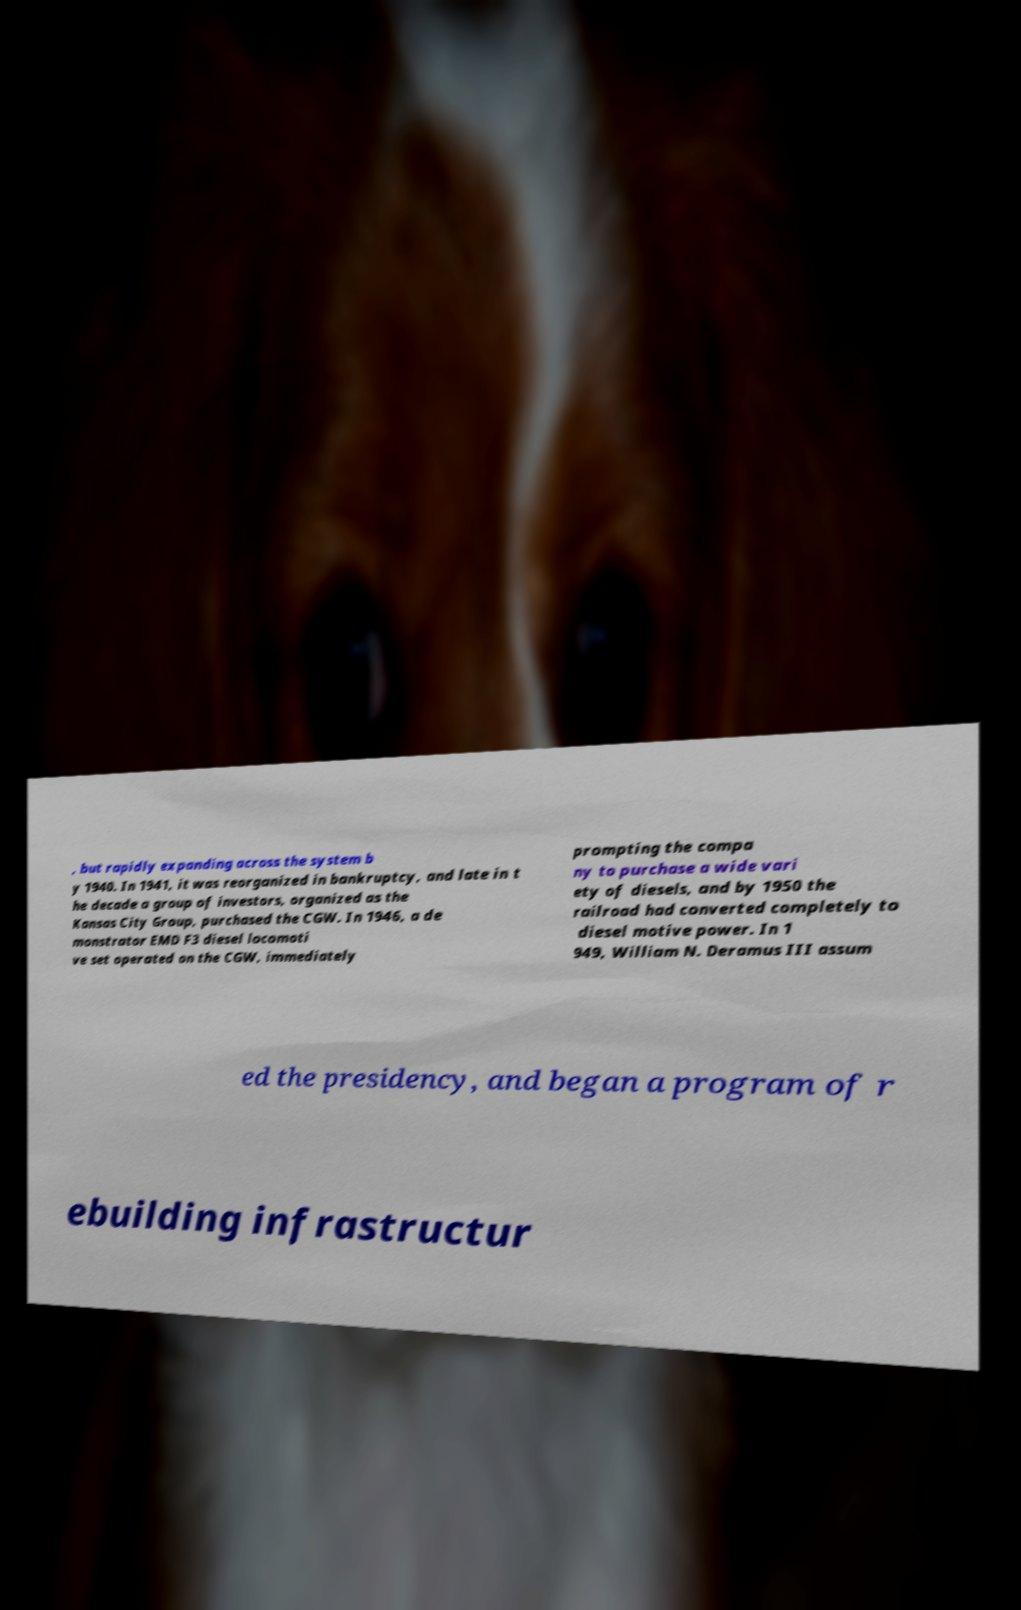I need the written content from this picture converted into text. Can you do that? , but rapidly expanding across the system b y 1940. In 1941, it was reorganized in bankruptcy, and late in t he decade a group of investors, organized as the Kansas City Group, purchased the CGW. In 1946, a de monstrator EMD F3 diesel locomoti ve set operated on the CGW, immediately prompting the compa ny to purchase a wide vari ety of diesels, and by 1950 the railroad had converted completely to diesel motive power. In 1 949, William N. Deramus III assum ed the presidency, and began a program of r ebuilding infrastructur 